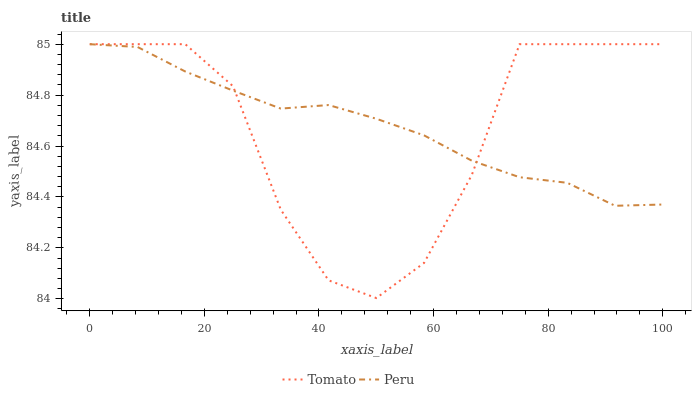Does Tomato have the minimum area under the curve?
Answer yes or no. Yes. Does Peru have the maximum area under the curve?
Answer yes or no. Yes. Does Peru have the minimum area under the curve?
Answer yes or no. No. Is Peru the smoothest?
Answer yes or no. Yes. Is Tomato the roughest?
Answer yes or no. Yes. Is Peru the roughest?
Answer yes or no. No. Does Tomato have the lowest value?
Answer yes or no. Yes. Does Peru have the lowest value?
Answer yes or no. No. Does Peru have the highest value?
Answer yes or no. Yes. Does Peru intersect Tomato?
Answer yes or no. Yes. Is Peru less than Tomato?
Answer yes or no. No. Is Peru greater than Tomato?
Answer yes or no. No. 